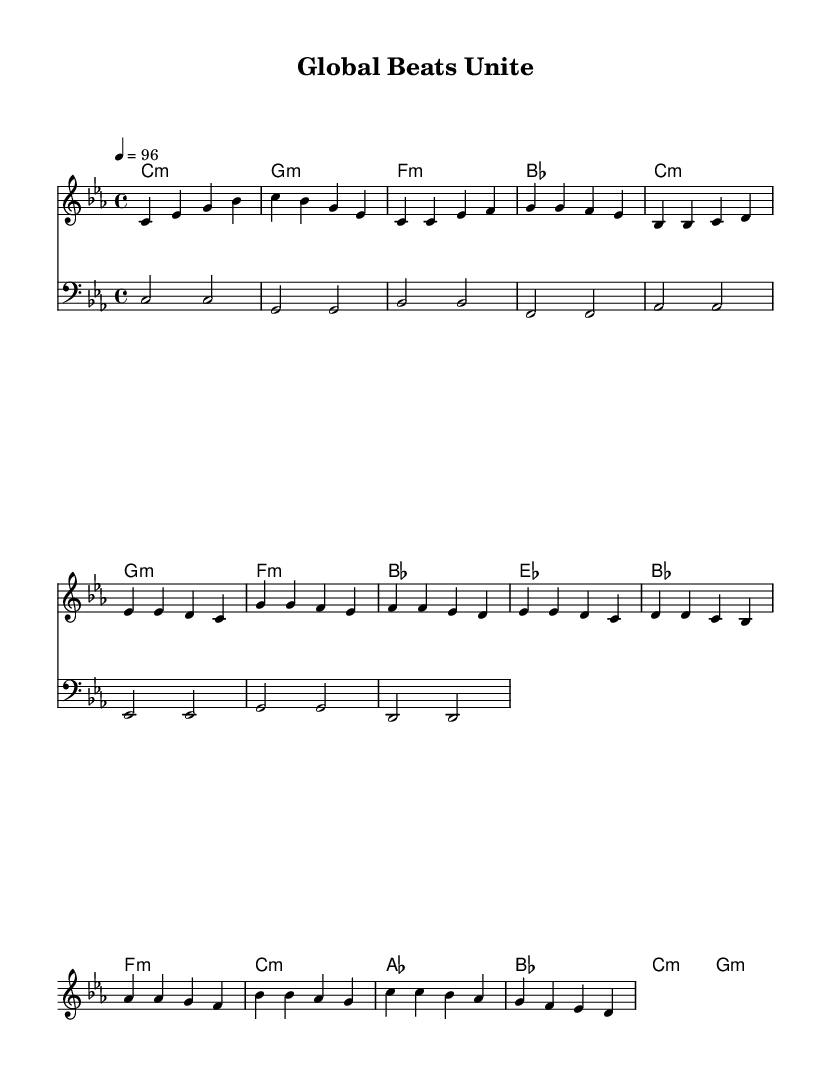What is the key signature of this music? The key signature is C minor, which includes three flats (B flat, E flat, and A flat).
Answer: C minor What is the time signature of the piece? The time signature is 4/4, indicating four beats per measure.
Answer: 4/4 What is the tempo marking indicated in the music? The tempo marking is 96 beats per minute, which suggests a moderately fast pace.
Answer: 96 How many measures are there in the chorus section? The chorus is made up of four measures, which can be counted by observing the measures where the melody and harmonies for the chorus are written.
Answer: 4 What is the last chord in the bridge? The last chord in the bridge is G minor, as indicated by the harmonization at the end of that section.
Answer: G minor What is the first note of the melody in the introduction? The first note of the melody is C in the fourth octave, which can be found at the beginning of the sheet music.
Answer: C How many times does the note E appear in the verse? The note E appears four times in the verse, which can be counted from the written melody notes in that section.
Answer: 4 